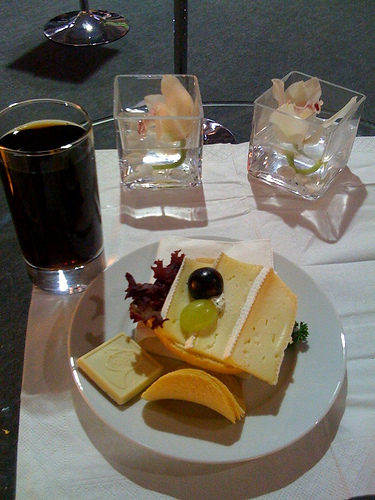<image>What is the flavor of the drink? It is not certain what the flavor of the drink is. It can be tea, coke, or even water. What is the flavor of the drink? I am not sure the flavor of the drink. It can be tea, coke, sweet or water. 